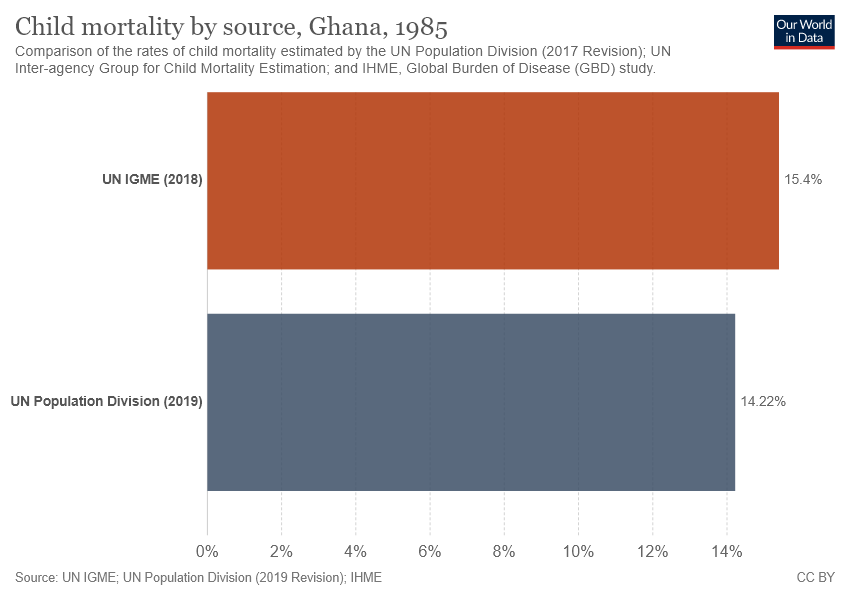Draw attention to some important aspects in this diagram. The two bars have a difference of 1.18... The value of the purple bar is 14.22. 